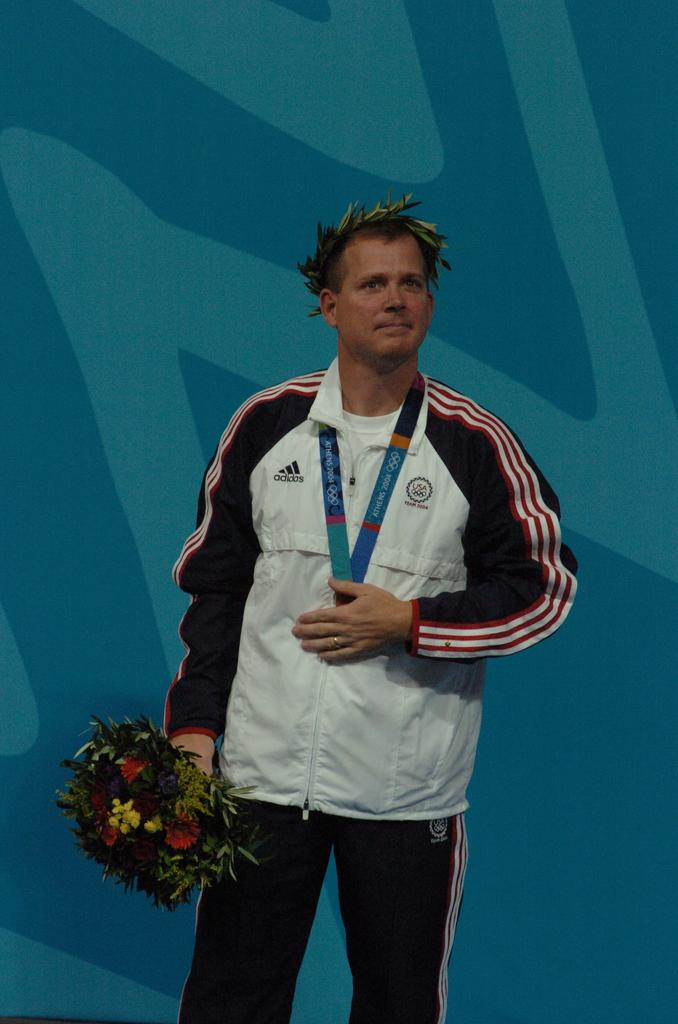<image>
Render a clear and concise summary of the photo. A man wearing an Adidas jacket holding flowers with an award ribbon around his neck. 